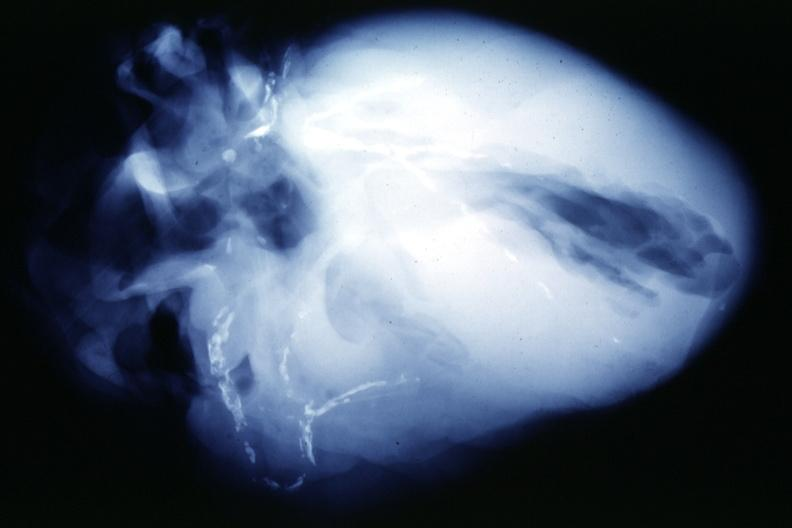s nipple duplication present?
Answer the question using a single word or phrase. No 